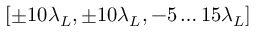Convert formula to latex. <formula><loc_0><loc_0><loc_500><loc_500>[ \pm 1 0 \lambda _ { L } , \pm 1 0 \lambda _ { L } , - 5 \dots 1 5 \lambda _ { L } ]</formula> 